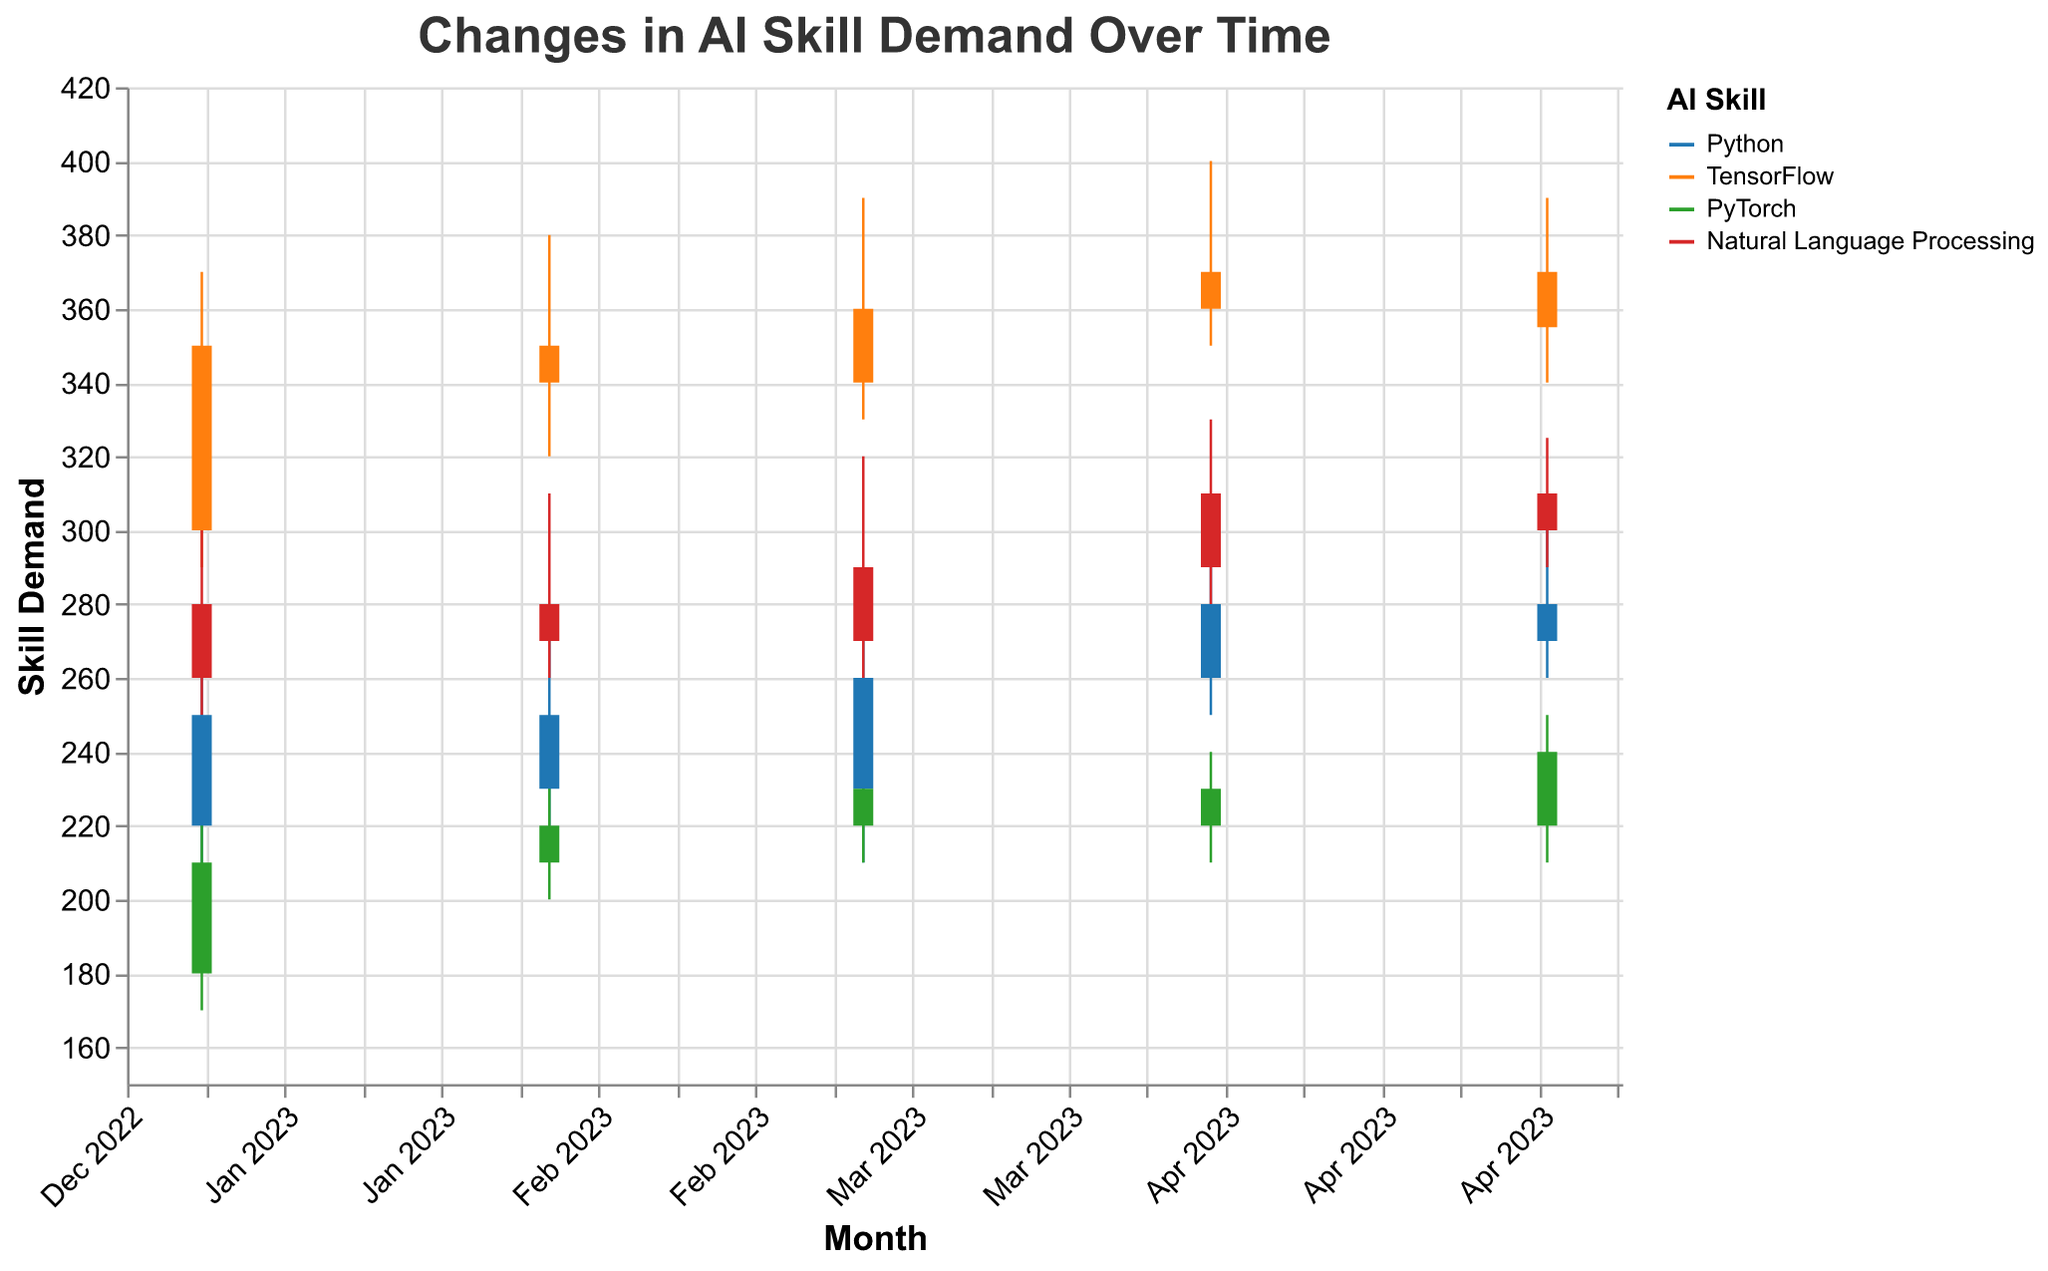What's the title of the chart? The title is prominently displayed at the top of the chart.
Answer: Changes in AI Skill Demand Over Time Which skill had the highest demand in May 2023? Look at the 'CandleClose' values for May 2023 across all skills and find the highest one. 'TensorFlow' had a 'CandleClose' value of 355, which is the highest.
Answer: TensorFlow Which month saw the biggest increase in Python skill demand? For each month, calculate the difference between 'CandleOpen' and 'CandleClose'. The month with the highest positive difference indicates the biggest increase. March 2023 saw an increase of 30 (260 - 230).
Answer: March 2023 Is there a month where the demand for PyTorch decreased? Compare 'CandleOpen' and 'CandleClose' values for each month for PyTorch. In April 2023, 'CandleClose' (220) is less than 'CandleOpen' (230).
Answer: April 2023 What is the lowest skill demand for Natural Language Processing in any month? Look at the 'Low' values for Natural Language Processing across all months and identify the minimum value. The lowest is 250 in January 2023.
Answer: 250 Which skill had the highest variability in demand over the period? Calculate the range (High - Low) for each skill in each month and then find the average range for each skill. TensorFlow has the highest range, varying from 370 to 290 (in January), creating the highest variability overall.
Answer: TensorFlow Between January and May 2023, which skill showed a consistent increase in demand? Observe the 'CandleClose' values for all months from January to May for each skill. For Natural Language Processing, values consistently increase until April. However, no skill shows an entirely consistent increase till May.
Answer: None What is the maximum demand recorded for any skill throughout the year? Find the maximum 'High' value across all skills and months. TensorFlow reached the highest demand of 400 in April 2023.
Answer: 400 How did the demand for TensorFlow change between March and April 2023? Compare 'CandleClose' values for TensorFlow between March and April 2023. The demand increased from 360 to 370.
Answer: Increased In terms of skill demand, how does PyTorch in April 2023 compare to Natural Language Processing in the same month? Compare 'CandleClose' values for both PyTorch and Natural Language Processing in April 2023. PyTorch's 'CandleClose' is 220 while Natural Language Processing's is 310.
Answer: Lower 